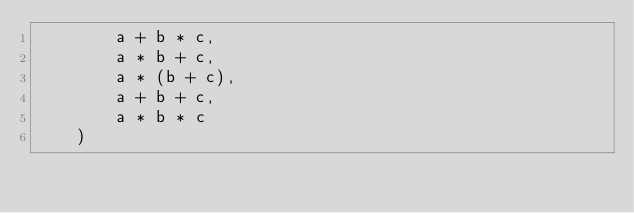Convert code to text. <code><loc_0><loc_0><loc_500><loc_500><_Python_>        a + b * c,
        a * b + c,
        a * (b + c),
        a + b + c,
        a * b * c
    )
</code> 